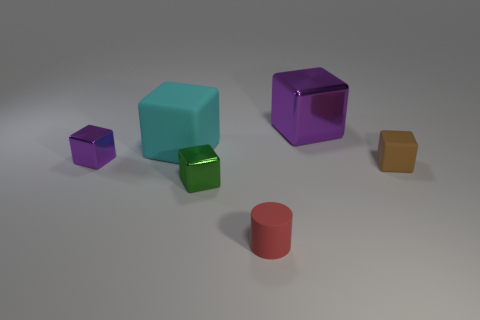What material is the cube that is the same color as the big metallic object?
Your answer should be very brief. Metal. What size is the brown matte thing that is the same shape as the green metal thing?
Your answer should be compact. Small. How many objects are rubber blocks in front of the cyan rubber block or tiny green metal objects?
Your answer should be very brief. 2. How many small matte things are left of the purple cube that is in front of the big block that is behind the cyan block?
Keep it short and to the point. 0. There is a small rubber thing that is to the left of the purple shiny thing that is on the right side of the small thing left of the big cyan object; what is its shape?
Ensure brevity in your answer.  Cylinder. How many other things are there of the same color as the large metallic object?
Offer a terse response. 1. What is the shape of the tiny matte thing that is left of the large thing behind the cyan rubber block?
Ensure brevity in your answer.  Cylinder. There is a small brown block; how many tiny brown blocks are in front of it?
Offer a very short reply. 0. Are there any tiny brown things that have the same material as the cyan thing?
Offer a terse response. Yes. There is a red cylinder that is the same size as the brown block; what is it made of?
Your response must be concise. Rubber. 